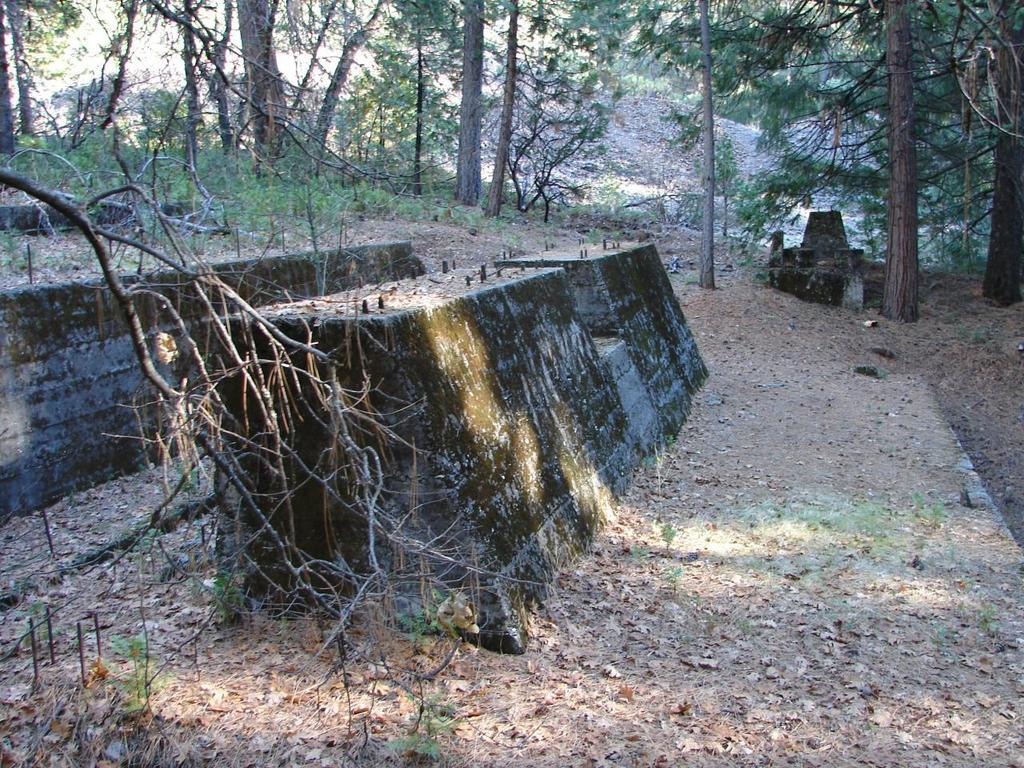What type of objects are made of concrete in the image? There are concrete blocks in the image. What type of natural vegetation is present in the image? There are trees in the image. Is there any evidence of an attack or war in the image? No, there is no evidence of an attack or war in the image. Can you see a ball being used in the image? No, there is no ball present in the image. 